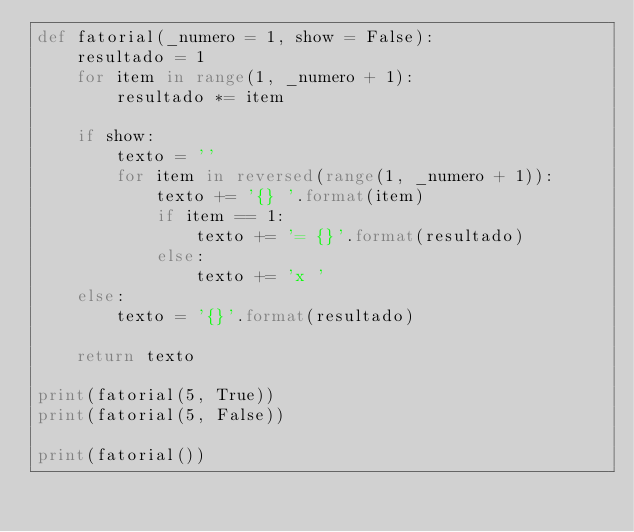Convert code to text. <code><loc_0><loc_0><loc_500><loc_500><_Python_>def fatorial(_numero = 1, show = False):
    resultado = 1
    for item in range(1, _numero + 1):
        resultado *= item

    if show:
        texto = ''
        for item in reversed(range(1, _numero + 1)):
            texto += '{} '.format(item)
            if item == 1:
                texto += '= {}'.format(resultado)
            else:
                texto += 'x '
    else:
        texto = '{}'.format(resultado)

    return texto

print(fatorial(5, True))
print(fatorial(5, False))

print(fatorial())</code> 